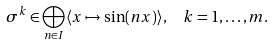Convert formula to latex. <formula><loc_0><loc_0><loc_500><loc_500>\sigma ^ { k } & \in \bigoplus _ { n \in I } \langle x \mapsto \sin ( n x ) \rangle , \quad k = 1 , \dots , m .</formula> 